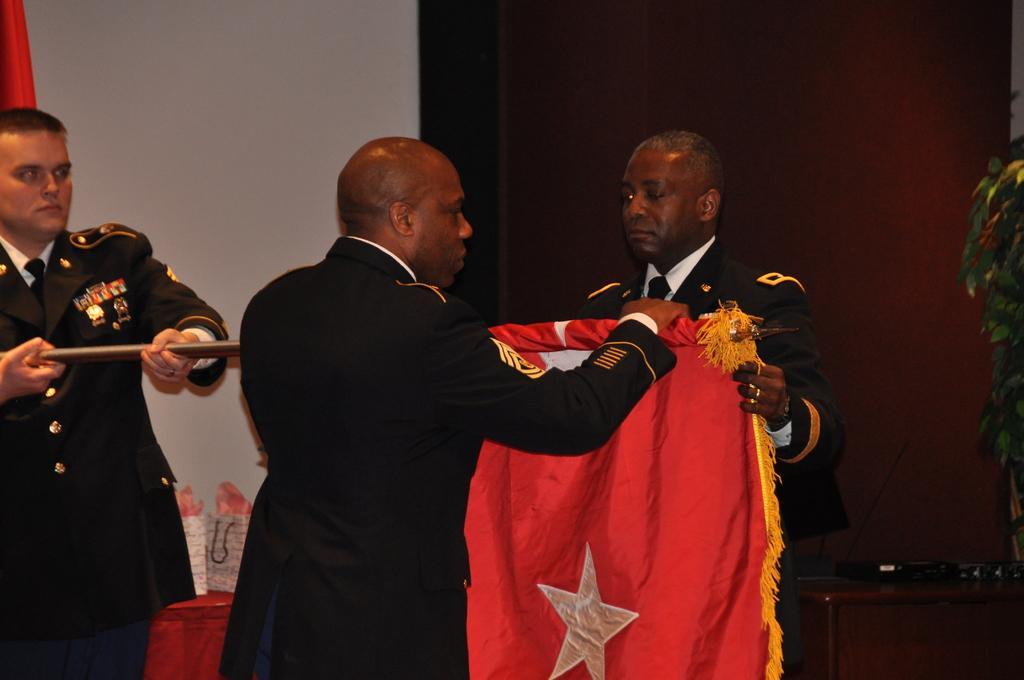Describe this image in one or two sentences. In this picture I can see few people standing and holding flag. 